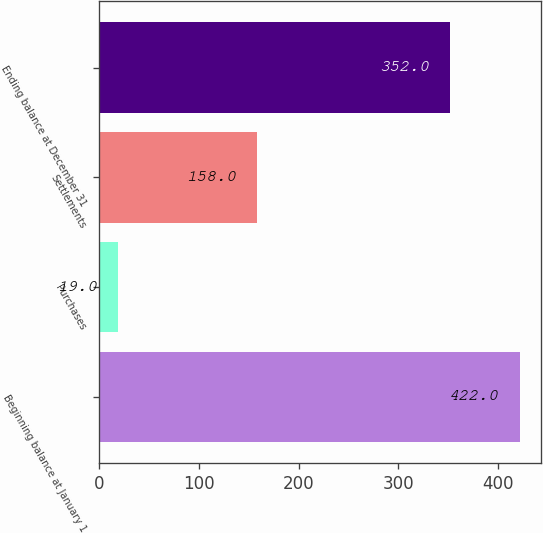Convert chart to OTSL. <chart><loc_0><loc_0><loc_500><loc_500><bar_chart><fcel>Beginning balance at January 1<fcel>Purchases<fcel>Settlements<fcel>Ending balance at December 31<nl><fcel>422<fcel>19<fcel>158<fcel>352<nl></chart> 